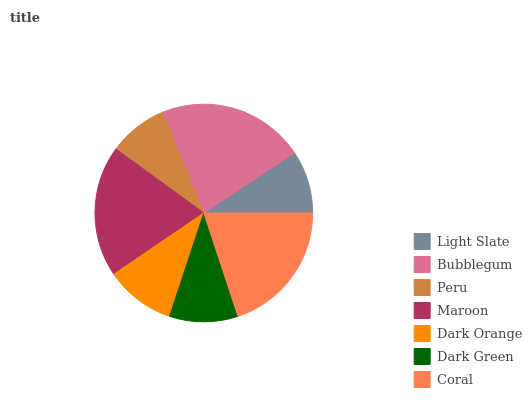Is Peru the minimum?
Answer yes or no. Yes. Is Bubblegum the maximum?
Answer yes or no. Yes. Is Bubblegum the minimum?
Answer yes or no. No. Is Peru the maximum?
Answer yes or no. No. Is Bubblegum greater than Peru?
Answer yes or no. Yes. Is Peru less than Bubblegum?
Answer yes or no. Yes. Is Peru greater than Bubblegum?
Answer yes or no. No. Is Bubblegum less than Peru?
Answer yes or no. No. Is Dark Orange the high median?
Answer yes or no. Yes. Is Dark Orange the low median?
Answer yes or no. Yes. Is Bubblegum the high median?
Answer yes or no. No. Is Maroon the low median?
Answer yes or no. No. 